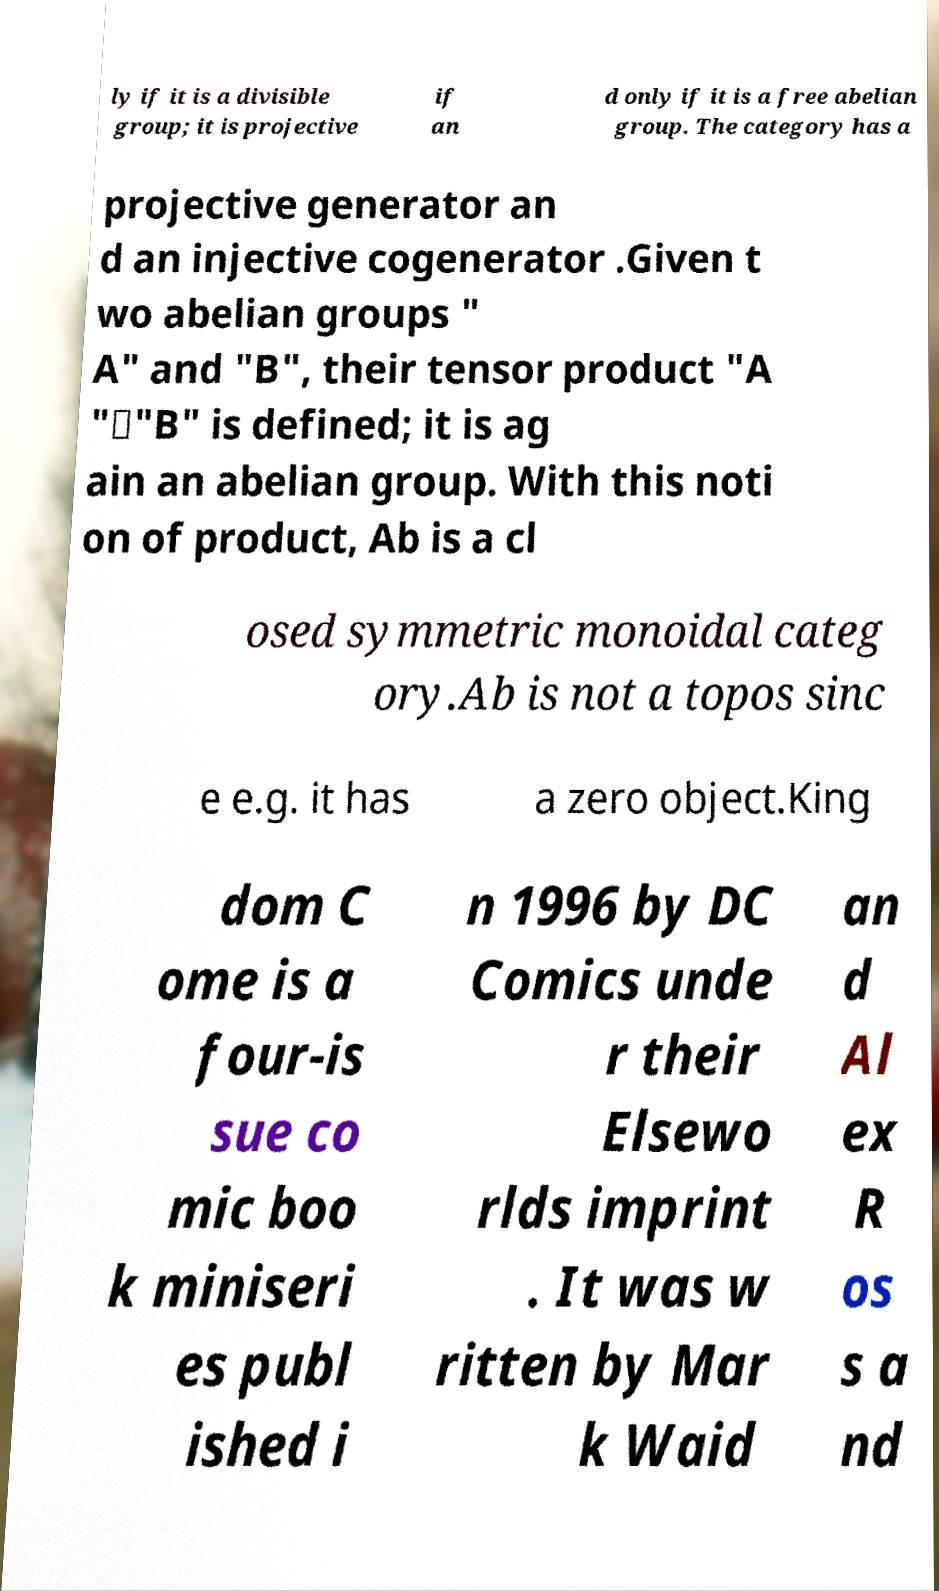For documentation purposes, I need the text within this image transcribed. Could you provide that? ly if it is a divisible group; it is projective if an d only if it is a free abelian group. The category has a projective generator an d an injective cogenerator .Given t wo abelian groups " A" and "B", their tensor product "A "⊗"B" is defined; it is ag ain an abelian group. With this noti on of product, Ab is a cl osed symmetric monoidal categ ory.Ab is not a topos sinc e e.g. it has a zero object.King dom C ome is a four-is sue co mic boo k miniseri es publ ished i n 1996 by DC Comics unde r their Elsewo rlds imprint . It was w ritten by Mar k Waid an d Al ex R os s a nd 